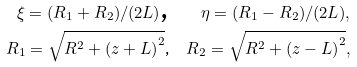<formula> <loc_0><loc_0><loc_500><loc_500>\xi = ( R _ { 1 } + R _ { 2 } ) / ( 2 L ) \text {,} \quad \eta = ( R _ { 1 } - R _ { 2 } ) / ( 2 L ) , \\ R _ { 1 } = \sqrt { R ^ { 2 } + \left ( z + L \right ) ^ { 2 } } \text {,} \quad R _ { 2 } = \sqrt { R ^ { 2 } + \left ( z - L \right ) ^ { 2 } } ,</formula> 